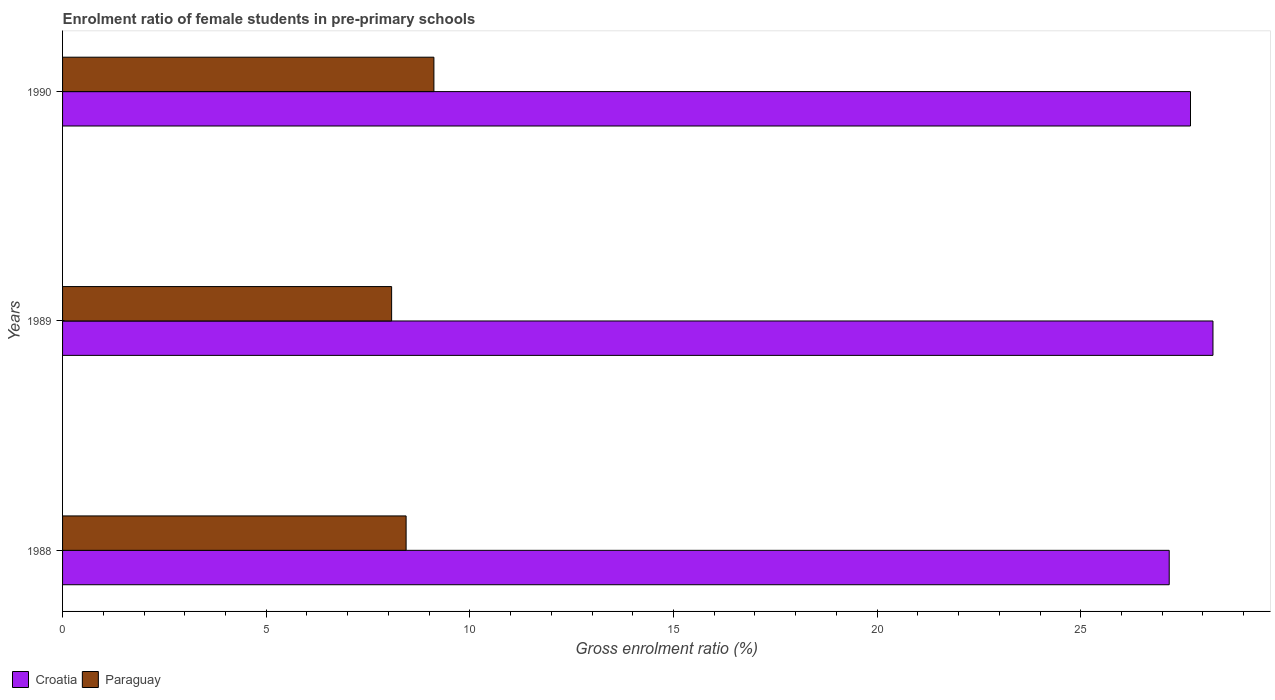How many different coloured bars are there?
Your response must be concise. 2. Are the number of bars on each tick of the Y-axis equal?
Keep it short and to the point. Yes. How many bars are there on the 3rd tick from the bottom?
Provide a short and direct response. 2. What is the enrolment ratio of female students in pre-primary schools in Croatia in 1990?
Make the answer very short. 27.69. Across all years, what is the maximum enrolment ratio of female students in pre-primary schools in Paraguay?
Offer a very short reply. 9.12. Across all years, what is the minimum enrolment ratio of female students in pre-primary schools in Croatia?
Your answer should be very brief. 27.17. In which year was the enrolment ratio of female students in pre-primary schools in Paraguay maximum?
Your answer should be very brief. 1990. In which year was the enrolment ratio of female students in pre-primary schools in Paraguay minimum?
Give a very brief answer. 1989. What is the total enrolment ratio of female students in pre-primary schools in Paraguay in the graph?
Provide a short and direct response. 25.63. What is the difference between the enrolment ratio of female students in pre-primary schools in Paraguay in 1988 and that in 1990?
Keep it short and to the point. -0.68. What is the difference between the enrolment ratio of female students in pre-primary schools in Croatia in 1988 and the enrolment ratio of female students in pre-primary schools in Paraguay in 1989?
Give a very brief answer. 19.09. What is the average enrolment ratio of female students in pre-primary schools in Paraguay per year?
Your response must be concise. 8.54. In the year 1989, what is the difference between the enrolment ratio of female students in pre-primary schools in Paraguay and enrolment ratio of female students in pre-primary schools in Croatia?
Provide a short and direct response. -20.17. What is the ratio of the enrolment ratio of female students in pre-primary schools in Croatia in 1989 to that in 1990?
Give a very brief answer. 1.02. Is the difference between the enrolment ratio of female students in pre-primary schools in Paraguay in 1989 and 1990 greater than the difference between the enrolment ratio of female students in pre-primary schools in Croatia in 1989 and 1990?
Offer a very short reply. No. What is the difference between the highest and the second highest enrolment ratio of female students in pre-primary schools in Croatia?
Provide a succinct answer. 0.55. What is the difference between the highest and the lowest enrolment ratio of female students in pre-primary schools in Paraguay?
Give a very brief answer. 1.04. What does the 1st bar from the top in 1990 represents?
Provide a short and direct response. Paraguay. What does the 1st bar from the bottom in 1989 represents?
Provide a succinct answer. Croatia. How many bars are there?
Keep it short and to the point. 6. How many years are there in the graph?
Offer a terse response. 3. What is the difference between two consecutive major ticks on the X-axis?
Provide a succinct answer. 5. Does the graph contain any zero values?
Offer a terse response. No. Where does the legend appear in the graph?
Keep it short and to the point. Bottom left. What is the title of the graph?
Provide a succinct answer. Enrolment ratio of female students in pre-primary schools. What is the label or title of the X-axis?
Offer a terse response. Gross enrolment ratio (%). What is the label or title of the Y-axis?
Provide a succinct answer. Years. What is the Gross enrolment ratio (%) of Croatia in 1988?
Offer a terse response. 27.17. What is the Gross enrolment ratio (%) in Paraguay in 1988?
Provide a short and direct response. 8.44. What is the Gross enrolment ratio (%) of Croatia in 1989?
Give a very brief answer. 28.25. What is the Gross enrolment ratio (%) of Paraguay in 1989?
Make the answer very short. 8.08. What is the Gross enrolment ratio (%) of Croatia in 1990?
Make the answer very short. 27.69. What is the Gross enrolment ratio (%) in Paraguay in 1990?
Ensure brevity in your answer.  9.12. Across all years, what is the maximum Gross enrolment ratio (%) of Croatia?
Offer a terse response. 28.25. Across all years, what is the maximum Gross enrolment ratio (%) in Paraguay?
Ensure brevity in your answer.  9.12. Across all years, what is the minimum Gross enrolment ratio (%) in Croatia?
Provide a short and direct response. 27.17. Across all years, what is the minimum Gross enrolment ratio (%) in Paraguay?
Offer a terse response. 8.08. What is the total Gross enrolment ratio (%) in Croatia in the graph?
Give a very brief answer. 83.11. What is the total Gross enrolment ratio (%) of Paraguay in the graph?
Give a very brief answer. 25.63. What is the difference between the Gross enrolment ratio (%) in Croatia in 1988 and that in 1989?
Ensure brevity in your answer.  -1.07. What is the difference between the Gross enrolment ratio (%) in Paraguay in 1988 and that in 1989?
Your answer should be compact. 0.36. What is the difference between the Gross enrolment ratio (%) of Croatia in 1988 and that in 1990?
Offer a very short reply. -0.52. What is the difference between the Gross enrolment ratio (%) of Paraguay in 1988 and that in 1990?
Keep it short and to the point. -0.68. What is the difference between the Gross enrolment ratio (%) of Croatia in 1989 and that in 1990?
Give a very brief answer. 0.55. What is the difference between the Gross enrolment ratio (%) of Paraguay in 1989 and that in 1990?
Your response must be concise. -1.04. What is the difference between the Gross enrolment ratio (%) of Croatia in 1988 and the Gross enrolment ratio (%) of Paraguay in 1989?
Offer a terse response. 19.09. What is the difference between the Gross enrolment ratio (%) in Croatia in 1988 and the Gross enrolment ratio (%) in Paraguay in 1990?
Your answer should be compact. 18.05. What is the difference between the Gross enrolment ratio (%) in Croatia in 1989 and the Gross enrolment ratio (%) in Paraguay in 1990?
Ensure brevity in your answer.  19.13. What is the average Gross enrolment ratio (%) in Croatia per year?
Offer a terse response. 27.7. What is the average Gross enrolment ratio (%) in Paraguay per year?
Keep it short and to the point. 8.54. In the year 1988, what is the difference between the Gross enrolment ratio (%) of Croatia and Gross enrolment ratio (%) of Paraguay?
Your answer should be very brief. 18.74. In the year 1989, what is the difference between the Gross enrolment ratio (%) in Croatia and Gross enrolment ratio (%) in Paraguay?
Your response must be concise. 20.17. In the year 1990, what is the difference between the Gross enrolment ratio (%) in Croatia and Gross enrolment ratio (%) in Paraguay?
Provide a short and direct response. 18.58. What is the ratio of the Gross enrolment ratio (%) in Croatia in 1988 to that in 1989?
Give a very brief answer. 0.96. What is the ratio of the Gross enrolment ratio (%) of Paraguay in 1988 to that in 1989?
Ensure brevity in your answer.  1.04. What is the ratio of the Gross enrolment ratio (%) of Croatia in 1988 to that in 1990?
Your response must be concise. 0.98. What is the ratio of the Gross enrolment ratio (%) of Paraguay in 1988 to that in 1990?
Give a very brief answer. 0.93. What is the ratio of the Gross enrolment ratio (%) in Croatia in 1989 to that in 1990?
Your response must be concise. 1.02. What is the ratio of the Gross enrolment ratio (%) in Paraguay in 1989 to that in 1990?
Your response must be concise. 0.89. What is the difference between the highest and the second highest Gross enrolment ratio (%) of Croatia?
Keep it short and to the point. 0.55. What is the difference between the highest and the second highest Gross enrolment ratio (%) of Paraguay?
Provide a succinct answer. 0.68. What is the difference between the highest and the lowest Gross enrolment ratio (%) in Croatia?
Offer a terse response. 1.07. What is the difference between the highest and the lowest Gross enrolment ratio (%) of Paraguay?
Ensure brevity in your answer.  1.04. 